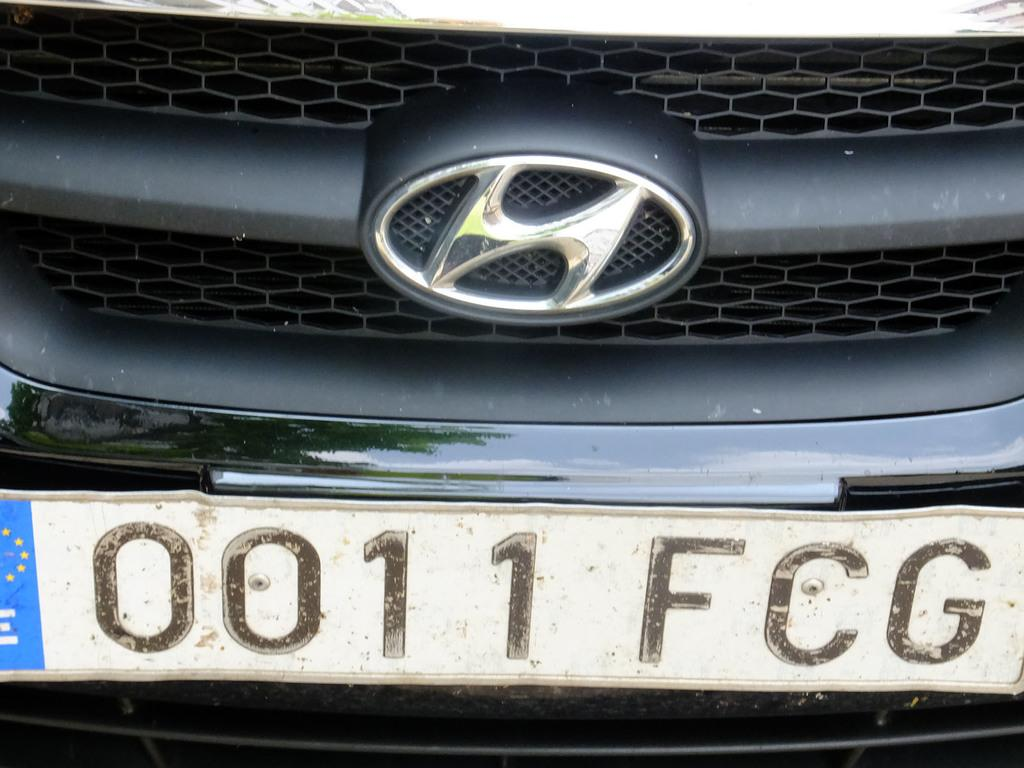<image>
Summarize the visual content of the image. Front of a Hyundai Car that has the license plate that says 0011 FCG. 